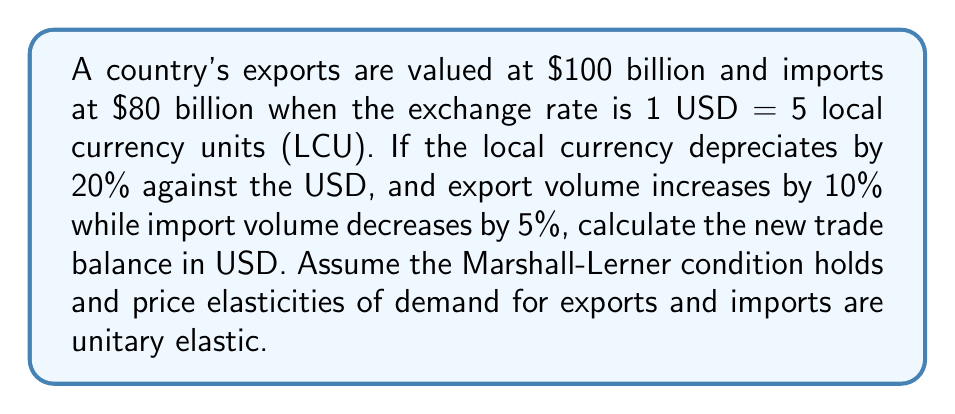Could you help me with this problem? Let's approach this step-by-step:

1) Initial situation:
   Exports = $100 billion
   Imports = $80 billion
   Trade Balance = $100b - $80b = $20 billion surplus

2) New exchange rate after 20% depreciation:
   1 USD = 5 * 1.20 = 6 LCU

3) Effect on exports:
   - Value in LCU remains the same (assuming unitary elasticity)
   - Volume increases by 10%
   New exports value: $100b * 1.10 = $110 billion

4) Effect on imports:
   - Price in LCU increases by 20%
   - Volume decreases by 5%
   New imports value: $80b * 1.20 * 0.95 = $91.2 billion

5) New trade balance:
   $110b - $91.2b = $18.8 billion surplus

The trade balance has decreased from $20 billion to $18.8 billion, a reduction of $1.2 billion.

This outcome is consistent with the J-curve effect, where currency depreciation can initially worsen the trade balance before improving it in the long run.
Answer: $18.8 billion surplus 